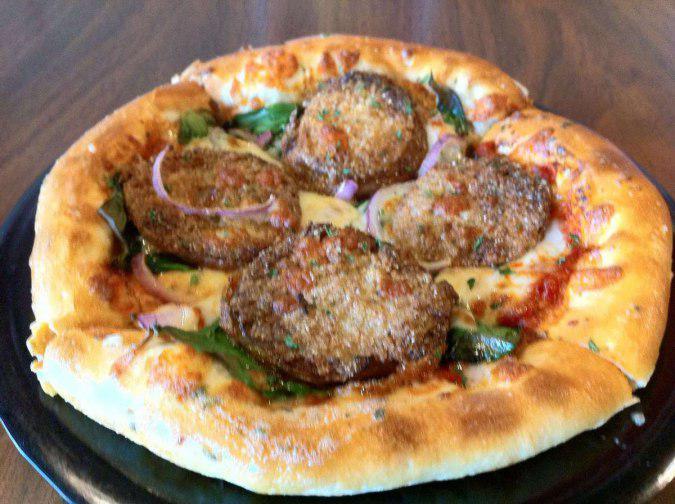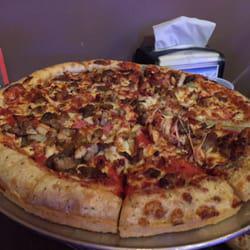The first image is the image on the left, the second image is the image on the right. Assess this claim about the two images: "There are at least 8 slices of a pizza sitting on top of a silver circle plate.". Correct or not? Answer yes or no. Yes. The first image is the image on the left, the second image is the image on the right. Examine the images to the left and right. Is the description "No pizza is missing a slice, but the pizza on the left has one slice out of alignment with the rest and is on a silver tray." accurate? Answer yes or no. No. 